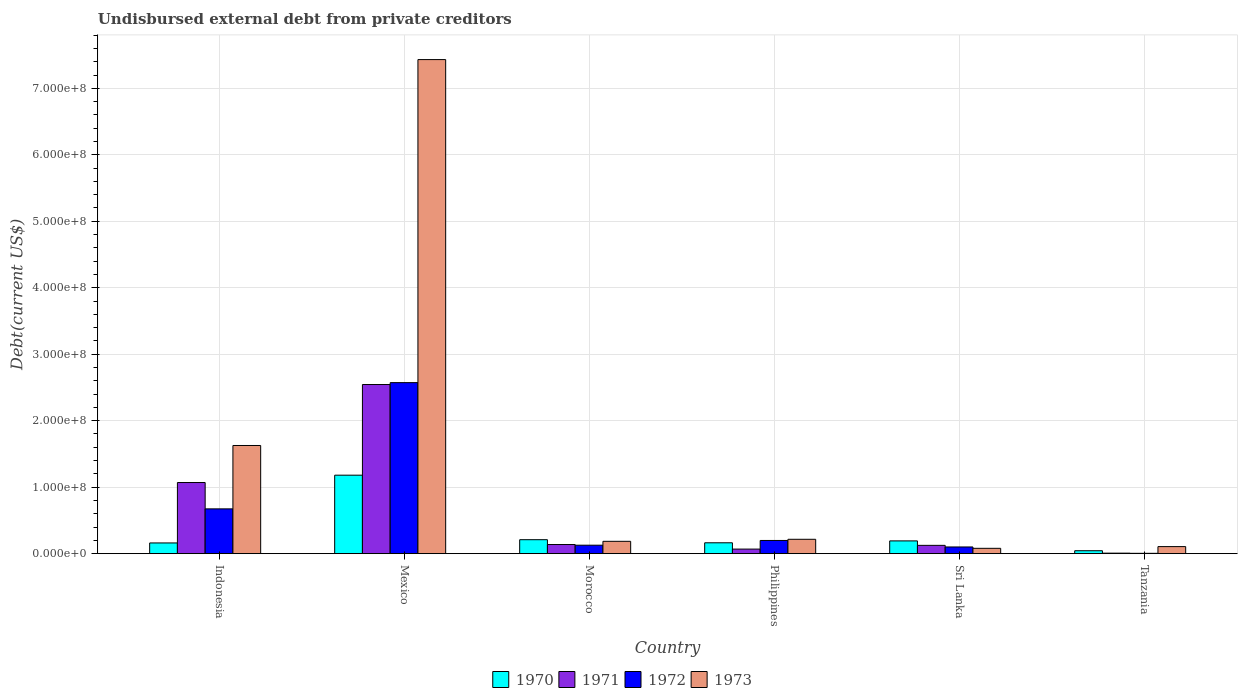How many different coloured bars are there?
Offer a terse response. 4. Are the number of bars on each tick of the X-axis equal?
Your answer should be compact. Yes. How many bars are there on the 5th tick from the left?
Provide a short and direct response. 4. How many bars are there on the 5th tick from the right?
Ensure brevity in your answer.  4. In how many cases, is the number of bars for a given country not equal to the number of legend labels?
Your answer should be compact. 0. What is the total debt in 1973 in Sri Lanka?
Make the answer very short. 8.03e+06. Across all countries, what is the maximum total debt in 1972?
Your answer should be very brief. 2.57e+08. Across all countries, what is the minimum total debt in 1970?
Provide a short and direct response. 4.40e+06. In which country was the total debt in 1970 maximum?
Make the answer very short. Mexico. In which country was the total debt in 1973 minimum?
Keep it short and to the point. Sri Lanka. What is the total total debt in 1970 in the graph?
Provide a short and direct response. 1.95e+08. What is the difference between the total debt in 1972 in Indonesia and that in Tanzania?
Make the answer very short. 6.69e+07. What is the difference between the total debt in 1972 in Mexico and the total debt in 1970 in Tanzania?
Make the answer very short. 2.53e+08. What is the average total debt in 1971 per country?
Your response must be concise. 6.59e+07. What is the difference between the total debt of/in 1973 and total debt of/in 1970 in Indonesia?
Your answer should be very brief. 1.47e+08. In how many countries, is the total debt in 1970 greater than 620000000 US$?
Your answer should be compact. 0. What is the ratio of the total debt in 1971 in Philippines to that in Tanzania?
Offer a terse response. 8.98. What is the difference between the highest and the second highest total debt in 1973?
Your answer should be very brief. 7.22e+08. What is the difference between the highest and the lowest total debt in 1970?
Ensure brevity in your answer.  1.14e+08. What is the difference between two consecutive major ticks on the Y-axis?
Ensure brevity in your answer.  1.00e+08. Are the values on the major ticks of Y-axis written in scientific E-notation?
Your answer should be very brief. Yes. Does the graph contain any zero values?
Provide a short and direct response. No. How many legend labels are there?
Make the answer very short. 4. What is the title of the graph?
Keep it short and to the point. Undisbursed external debt from private creditors. What is the label or title of the X-axis?
Your answer should be compact. Country. What is the label or title of the Y-axis?
Give a very brief answer. Debt(current US$). What is the Debt(current US$) in 1970 in Indonesia?
Your answer should be compact. 1.61e+07. What is the Debt(current US$) of 1971 in Indonesia?
Your response must be concise. 1.07e+08. What is the Debt(current US$) of 1972 in Indonesia?
Your response must be concise. 6.74e+07. What is the Debt(current US$) in 1973 in Indonesia?
Provide a succinct answer. 1.63e+08. What is the Debt(current US$) of 1970 in Mexico?
Give a very brief answer. 1.18e+08. What is the Debt(current US$) in 1971 in Mexico?
Provide a succinct answer. 2.54e+08. What is the Debt(current US$) in 1972 in Mexico?
Make the answer very short. 2.57e+08. What is the Debt(current US$) of 1973 in Mexico?
Your response must be concise. 7.43e+08. What is the Debt(current US$) in 1970 in Morocco?
Your response must be concise. 2.10e+07. What is the Debt(current US$) of 1971 in Morocco?
Keep it short and to the point. 1.37e+07. What is the Debt(current US$) of 1972 in Morocco?
Provide a short and direct response. 1.27e+07. What is the Debt(current US$) of 1973 in Morocco?
Make the answer very short. 1.86e+07. What is the Debt(current US$) of 1970 in Philippines?
Your answer should be very brief. 1.64e+07. What is the Debt(current US$) in 1971 in Philippines?
Your answer should be very brief. 6.87e+06. What is the Debt(current US$) of 1972 in Philippines?
Your answer should be compact. 1.99e+07. What is the Debt(current US$) of 1973 in Philippines?
Offer a terse response. 2.16e+07. What is the Debt(current US$) in 1970 in Sri Lanka?
Your response must be concise. 1.92e+07. What is the Debt(current US$) in 1971 in Sri Lanka?
Ensure brevity in your answer.  1.25e+07. What is the Debt(current US$) in 1972 in Sri Lanka?
Offer a very short reply. 1.01e+07. What is the Debt(current US$) of 1973 in Sri Lanka?
Provide a short and direct response. 8.03e+06. What is the Debt(current US$) in 1970 in Tanzania?
Your response must be concise. 4.40e+06. What is the Debt(current US$) of 1971 in Tanzania?
Provide a succinct answer. 7.65e+05. What is the Debt(current US$) in 1972 in Tanzania?
Give a very brief answer. 5.15e+05. What is the Debt(current US$) of 1973 in Tanzania?
Ensure brevity in your answer.  1.06e+07. Across all countries, what is the maximum Debt(current US$) of 1970?
Your answer should be very brief. 1.18e+08. Across all countries, what is the maximum Debt(current US$) of 1971?
Give a very brief answer. 2.54e+08. Across all countries, what is the maximum Debt(current US$) in 1972?
Offer a very short reply. 2.57e+08. Across all countries, what is the maximum Debt(current US$) of 1973?
Offer a very short reply. 7.43e+08. Across all countries, what is the minimum Debt(current US$) in 1970?
Provide a succinct answer. 4.40e+06. Across all countries, what is the minimum Debt(current US$) of 1971?
Give a very brief answer. 7.65e+05. Across all countries, what is the minimum Debt(current US$) of 1972?
Offer a terse response. 5.15e+05. Across all countries, what is the minimum Debt(current US$) in 1973?
Your answer should be compact. 8.03e+06. What is the total Debt(current US$) of 1970 in the graph?
Make the answer very short. 1.95e+08. What is the total Debt(current US$) of 1971 in the graph?
Make the answer very short. 3.95e+08. What is the total Debt(current US$) in 1972 in the graph?
Your answer should be very brief. 3.68e+08. What is the total Debt(current US$) of 1973 in the graph?
Offer a terse response. 9.65e+08. What is the difference between the Debt(current US$) in 1970 in Indonesia and that in Mexico?
Your answer should be very brief. -1.02e+08. What is the difference between the Debt(current US$) in 1971 in Indonesia and that in Mexico?
Keep it short and to the point. -1.47e+08. What is the difference between the Debt(current US$) in 1972 in Indonesia and that in Mexico?
Your answer should be very brief. -1.90e+08. What is the difference between the Debt(current US$) of 1973 in Indonesia and that in Mexico?
Offer a very short reply. -5.81e+08. What is the difference between the Debt(current US$) of 1970 in Indonesia and that in Morocco?
Your answer should be compact. -4.89e+06. What is the difference between the Debt(current US$) in 1971 in Indonesia and that in Morocco?
Offer a very short reply. 9.33e+07. What is the difference between the Debt(current US$) of 1972 in Indonesia and that in Morocco?
Ensure brevity in your answer.  5.46e+07. What is the difference between the Debt(current US$) of 1973 in Indonesia and that in Morocco?
Make the answer very short. 1.44e+08. What is the difference between the Debt(current US$) in 1970 in Indonesia and that in Philippines?
Give a very brief answer. -2.28e+05. What is the difference between the Debt(current US$) in 1971 in Indonesia and that in Philippines?
Make the answer very short. 1.00e+08. What is the difference between the Debt(current US$) of 1972 in Indonesia and that in Philippines?
Your answer should be very brief. 4.75e+07. What is the difference between the Debt(current US$) of 1973 in Indonesia and that in Philippines?
Keep it short and to the point. 1.41e+08. What is the difference between the Debt(current US$) of 1970 in Indonesia and that in Sri Lanka?
Your answer should be compact. -3.08e+06. What is the difference between the Debt(current US$) in 1971 in Indonesia and that in Sri Lanka?
Make the answer very short. 9.45e+07. What is the difference between the Debt(current US$) of 1972 in Indonesia and that in Sri Lanka?
Give a very brief answer. 5.73e+07. What is the difference between the Debt(current US$) in 1973 in Indonesia and that in Sri Lanka?
Offer a terse response. 1.55e+08. What is the difference between the Debt(current US$) of 1970 in Indonesia and that in Tanzania?
Ensure brevity in your answer.  1.17e+07. What is the difference between the Debt(current US$) of 1971 in Indonesia and that in Tanzania?
Offer a very short reply. 1.06e+08. What is the difference between the Debt(current US$) of 1972 in Indonesia and that in Tanzania?
Keep it short and to the point. 6.69e+07. What is the difference between the Debt(current US$) of 1973 in Indonesia and that in Tanzania?
Provide a short and direct response. 1.52e+08. What is the difference between the Debt(current US$) of 1970 in Mexico and that in Morocco?
Provide a short and direct response. 9.70e+07. What is the difference between the Debt(current US$) of 1971 in Mexico and that in Morocco?
Provide a succinct answer. 2.41e+08. What is the difference between the Debt(current US$) in 1972 in Mexico and that in Morocco?
Give a very brief answer. 2.45e+08. What is the difference between the Debt(current US$) of 1973 in Mexico and that in Morocco?
Your answer should be very brief. 7.25e+08. What is the difference between the Debt(current US$) in 1970 in Mexico and that in Philippines?
Your response must be concise. 1.02e+08. What is the difference between the Debt(current US$) in 1971 in Mexico and that in Philippines?
Your response must be concise. 2.48e+08. What is the difference between the Debt(current US$) in 1972 in Mexico and that in Philippines?
Ensure brevity in your answer.  2.37e+08. What is the difference between the Debt(current US$) of 1973 in Mexico and that in Philippines?
Provide a short and direct response. 7.22e+08. What is the difference between the Debt(current US$) of 1970 in Mexico and that in Sri Lanka?
Your answer should be very brief. 9.88e+07. What is the difference between the Debt(current US$) of 1971 in Mexico and that in Sri Lanka?
Give a very brief answer. 2.42e+08. What is the difference between the Debt(current US$) of 1972 in Mexico and that in Sri Lanka?
Make the answer very short. 2.47e+08. What is the difference between the Debt(current US$) in 1973 in Mexico and that in Sri Lanka?
Give a very brief answer. 7.35e+08. What is the difference between the Debt(current US$) of 1970 in Mexico and that in Tanzania?
Give a very brief answer. 1.14e+08. What is the difference between the Debt(current US$) in 1971 in Mexico and that in Tanzania?
Your response must be concise. 2.54e+08. What is the difference between the Debt(current US$) of 1972 in Mexico and that in Tanzania?
Your answer should be compact. 2.57e+08. What is the difference between the Debt(current US$) in 1973 in Mexico and that in Tanzania?
Provide a succinct answer. 7.33e+08. What is the difference between the Debt(current US$) in 1970 in Morocco and that in Philippines?
Offer a very short reply. 4.66e+06. What is the difference between the Debt(current US$) in 1971 in Morocco and that in Philippines?
Provide a succinct answer. 6.88e+06. What is the difference between the Debt(current US$) of 1972 in Morocco and that in Philippines?
Ensure brevity in your answer.  -7.12e+06. What is the difference between the Debt(current US$) of 1973 in Morocco and that in Philippines?
Offer a terse response. -3.06e+06. What is the difference between the Debt(current US$) in 1970 in Morocco and that in Sri Lanka?
Your response must be concise. 1.82e+06. What is the difference between the Debt(current US$) in 1971 in Morocco and that in Sri Lanka?
Offer a very short reply. 1.26e+06. What is the difference between the Debt(current US$) in 1972 in Morocco and that in Sri Lanka?
Offer a very short reply. 2.67e+06. What is the difference between the Debt(current US$) in 1973 in Morocco and that in Sri Lanka?
Your answer should be very brief. 1.05e+07. What is the difference between the Debt(current US$) in 1970 in Morocco and that in Tanzania?
Provide a short and direct response. 1.66e+07. What is the difference between the Debt(current US$) in 1971 in Morocco and that in Tanzania?
Give a very brief answer. 1.30e+07. What is the difference between the Debt(current US$) of 1972 in Morocco and that in Tanzania?
Keep it short and to the point. 1.22e+07. What is the difference between the Debt(current US$) of 1973 in Morocco and that in Tanzania?
Make the answer very short. 7.94e+06. What is the difference between the Debt(current US$) in 1970 in Philippines and that in Sri Lanka?
Your answer should be very brief. -2.85e+06. What is the difference between the Debt(current US$) in 1971 in Philippines and that in Sri Lanka?
Keep it short and to the point. -5.62e+06. What is the difference between the Debt(current US$) of 1972 in Philippines and that in Sri Lanka?
Make the answer very short. 9.78e+06. What is the difference between the Debt(current US$) in 1973 in Philippines and that in Sri Lanka?
Offer a terse response. 1.36e+07. What is the difference between the Debt(current US$) in 1970 in Philippines and that in Tanzania?
Your response must be concise. 1.20e+07. What is the difference between the Debt(current US$) in 1971 in Philippines and that in Tanzania?
Your answer should be compact. 6.11e+06. What is the difference between the Debt(current US$) of 1972 in Philippines and that in Tanzania?
Your answer should be very brief. 1.93e+07. What is the difference between the Debt(current US$) of 1973 in Philippines and that in Tanzania?
Offer a terse response. 1.10e+07. What is the difference between the Debt(current US$) of 1970 in Sri Lanka and that in Tanzania?
Your answer should be compact. 1.48e+07. What is the difference between the Debt(current US$) in 1971 in Sri Lanka and that in Tanzania?
Your answer should be very brief. 1.17e+07. What is the difference between the Debt(current US$) of 1972 in Sri Lanka and that in Tanzania?
Your answer should be very brief. 9.56e+06. What is the difference between the Debt(current US$) in 1973 in Sri Lanka and that in Tanzania?
Your response must be concise. -2.59e+06. What is the difference between the Debt(current US$) in 1970 in Indonesia and the Debt(current US$) in 1971 in Mexico?
Provide a succinct answer. -2.38e+08. What is the difference between the Debt(current US$) of 1970 in Indonesia and the Debt(current US$) of 1972 in Mexico?
Provide a succinct answer. -2.41e+08. What is the difference between the Debt(current US$) in 1970 in Indonesia and the Debt(current US$) in 1973 in Mexico?
Your answer should be compact. -7.27e+08. What is the difference between the Debt(current US$) in 1971 in Indonesia and the Debt(current US$) in 1972 in Mexico?
Your answer should be very brief. -1.50e+08. What is the difference between the Debt(current US$) of 1971 in Indonesia and the Debt(current US$) of 1973 in Mexico?
Your response must be concise. -6.36e+08. What is the difference between the Debt(current US$) of 1972 in Indonesia and the Debt(current US$) of 1973 in Mexico?
Give a very brief answer. -6.76e+08. What is the difference between the Debt(current US$) of 1970 in Indonesia and the Debt(current US$) of 1971 in Morocco?
Your answer should be compact. 2.38e+06. What is the difference between the Debt(current US$) in 1970 in Indonesia and the Debt(current US$) in 1972 in Morocco?
Your response must be concise. 3.39e+06. What is the difference between the Debt(current US$) in 1970 in Indonesia and the Debt(current US$) in 1973 in Morocco?
Your response must be concise. -2.44e+06. What is the difference between the Debt(current US$) of 1971 in Indonesia and the Debt(current US$) of 1972 in Morocco?
Offer a very short reply. 9.43e+07. What is the difference between the Debt(current US$) in 1971 in Indonesia and the Debt(current US$) in 1973 in Morocco?
Give a very brief answer. 8.85e+07. What is the difference between the Debt(current US$) of 1972 in Indonesia and the Debt(current US$) of 1973 in Morocco?
Give a very brief answer. 4.88e+07. What is the difference between the Debt(current US$) of 1970 in Indonesia and the Debt(current US$) of 1971 in Philippines?
Your answer should be very brief. 9.25e+06. What is the difference between the Debt(current US$) in 1970 in Indonesia and the Debt(current US$) in 1972 in Philippines?
Ensure brevity in your answer.  -3.73e+06. What is the difference between the Debt(current US$) of 1970 in Indonesia and the Debt(current US$) of 1973 in Philippines?
Make the answer very short. -5.49e+06. What is the difference between the Debt(current US$) of 1971 in Indonesia and the Debt(current US$) of 1972 in Philippines?
Give a very brief answer. 8.72e+07. What is the difference between the Debt(current US$) of 1971 in Indonesia and the Debt(current US$) of 1973 in Philippines?
Give a very brief answer. 8.54e+07. What is the difference between the Debt(current US$) of 1972 in Indonesia and the Debt(current US$) of 1973 in Philippines?
Your response must be concise. 4.58e+07. What is the difference between the Debt(current US$) of 1970 in Indonesia and the Debt(current US$) of 1971 in Sri Lanka?
Ensure brevity in your answer.  3.63e+06. What is the difference between the Debt(current US$) of 1970 in Indonesia and the Debt(current US$) of 1972 in Sri Lanka?
Provide a short and direct response. 6.05e+06. What is the difference between the Debt(current US$) of 1970 in Indonesia and the Debt(current US$) of 1973 in Sri Lanka?
Your answer should be very brief. 8.10e+06. What is the difference between the Debt(current US$) in 1971 in Indonesia and the Debt(current US$) in 1972 in Sri Lanka?
Your answer should be compact. 9.69e+07. What is the difference between the Debt(current US$) in 1971 in Indonesia and the Debt(current US$) in 1973 in Sri Lanka?
Ensure brevity in your answer.  9.90e+07. What is the difference between the Debt(current US$) of 1972 in Indonesia and the Debt(current US$) of 1973 in Sri Lanka?
Offer a very short reply. 5.93e+07. What is the difference between the Debt(current US$) in 1970 in Indonesia and the Debt(current US$) in 1971 in Tanzania?
Your answer should be compact. 1.54e+07. What is the difference between the Debt(current US$) of 1970 in Indonesia and the Debt(current US$) of 1972 in Tanzania?
Offer a terse response. 1.56e+07. What is the difference between the Debt(current US$) in 1970 in Indonesia and the Debt(current US$) in 1973 in Tanzania?
Give a very brief answer. 5.51e+06. What is the difference between the Debt(current US$) in 1971 in Indonesia and the Debt(current US$) in 1972 in Tanzania?
Offer a very short reply. 1.06e+08. What is the difference between the Debt(current US$) in 1971 in Indonesia and the Debt(current US$) in 1973 in Tanzania?
Make the answer very short. 9.64e+07. What is the difference between the Debt(current US$) of 1972 in Indonesia and the Debt(current US$) of 1973 in Tanzania?
Offer a very short reply. 5.68e+07. What is the difference between the Debt(current US$) in 1970 in Mexico and the Debt(current US$) in 1971 in Morocco?
Offer a terse response. 1.04e+08. What is the difference between the Debt(current US$) in 1970 in Mexico and the Debt(current US$) in 1972 in Morocco?
Your response must be concise. 1.05e+08. What is the difference between the Debt(current US$) in 1970 in Mexico and the Debt(current US$) in 1973 in Morocco?
Offer a terse response. 9.95e+07. What is the difference between the Debt(current US$) in 1971 in Mexico and the Debt(current US$) in 1972 in Morocco?
Your answer should be compact. 2.42e+08. What is the difference between the Debt(current US$) in 1971 in Mexico and the Debt(current US$) in 1973 in Morocco?
Offer a terse response. 2.36e+08. What is the difference between the Debt(current US$) of 1972 in Mexico and the Debt(current US$) of 1973 in Morocco?
Give a very brief answer. 2.39e+08. What is the difference between the Debt(current US$) of 1970 in Mexico and the Debt(current US$) of 1971 in Philippines?
Your answer should be compact. 1.11e+08. What is the difference between the Debt(current US$) in 1970 in Mexico and the Debt(current US$) in 1972 in Philippines?
Your answer should be compact. 9.82e+07. What is the difference between the Debt(current US$) in 1970 in Mexico and the Debt(current US$) in 1973 in Philippines?
Offer a very short reply. 9.64e+07. What is the difference between the Debt(current US$) of 1971 in Mexico and the Debt(current US$) of 1972 in Philippines?
Your response must be concise. 2.35e+08. What is the difference between the Debt(current US$) of 1971 in Mexico and the Debt(current US$) of 1973 in Philippines?
Ensure brevity in your answer.  2.33e+08. What is the difference between the Debt(current US$) of 1972 in Mexico and the Debt(current US$) of 1973 in Philippines?
Make the answer very short. 2.36e+08. What is the difference between the Debt(current US$) of 1970 in Mexico and the Debt(current US$) of 1971 in Sri Lanka?
Provide a succinct answer. 1.06e+08. What is the difference between the Debt(current US$) of 1970 in Mexico and the Debt(current US$) of 1972 in Sri Lanka?
Provide a short and direct response. 1.08e+08. What is the difference between the Debt(current US$) in 1970 in Mexico and the Debt(current US$) in 1973 in Sri Lanka?
Offer a terse response. 1.10e+08. What is the difference between the Debt(current US$) of 1971 in Mexico and the Debt(current US$) of 1972 in Sri Lanka?
Provide a short and direct response. 2.44e+08. What is the difference between the Debt(current US$) of 1971 in Mexico and the Debt(current US$) of 1973 in Sri Lanka?
Offer a very short reply. 2.46e+08. What is the difference between the Debt(current US$) in 1972 in Mexico and the Debt(current US$) in 1973 in Sri Lanka?
Give a very brief answer. 2.49e+08. What is the difference between the Debt(current US$) of 1970 in Mexico and the Debt(current US$) of 1971 in Tanzania?
Keep it short and to the point. 1.17e+08. What is the difference between the Debt(current US$) of 1970 in Mexico and the Debt(current US$) of 1972 in Tanzania?
Give a very brief answer. 1.18e+08. What is the difference between the Debt(current US$) in 1970 in Mexico and the Debt(current US$) in 1973 in Tanzania?
Your response must be concise. 1.07e+08. What is the difference between the Debt(current US$) of 1971 in Mexico and the Debt(current US$) of 1972 in Tanzania?
Your answer should be compact. 2.54e+08. What is the difference between the Debt(current US$) of 1971 in Mexico and the Debt(current US$) of 1973 in Tanzania?
Offer a very short reply. 2.44e+08. What is the difference between the Debt(current US$) of 1972 in Mexico and the Debt(current US$) of 1973 in Tanzania?
Keep it short and to the point. 2.47e+08. What is the difference between the Debt(current US$) in 1970 in Morocco and the Debt(current US$) in 1971 in Philippines?
Offer a terse response. 1.41e+07. What is the difference between the Debt(current US$) of 1970 in Morocco and the Debt(current US$) of 1972 in Philippines?
Your answer should be very brief. 1.16e+06. What is the difference between the Debt(current US$) in 1970 in Morocco and the Debt(current US$) in 1973 in Philippines?
Your answer should be compact. -6.03e+05. What is the difference between the Debt(current US$) of 1971 in Morocco and the Debt(current US$) of 1972 in Philippines?
Your answer should be very brief. -6.10e+06. What is the difference between the Debt(current US$) in 1971 in Morocco and the Debt(current US$) in 1973 in Philippines?
Offer a terse response. -7.87e+06. What is the difference between the Debt(current US$) in 1972 in Morocco and the Debt(current US$) in 1973 in Philippines?
Your answer should be compact. -8.88e+06. What is the difference between the Debt(current US$) of 1970 in Morocco and the Debt(current US$) of 1971 in Sri Lanka?
Provide a succinct answer. 8.52e+06. What is the difference between the Debt(current US$) in 1970 in Morocco and the Debt(current US$) in 1972 in Sri Lanka?
Provide a short and direct response. 1.09e+07. What is the difference between the Debt(current US$) of 1970 in Morocco and the Debt(current US$) of 1973 in Sri Lanka?
Your answer should be very brief. 1.30e+07. What is the difference between the Debt(current US$) in 1971 in Morocco and the Debt(current US$) in 1972 in Sri Lanka?
Make the answer very short. 3.68e+06. What is the difference between the Debt(current US$) in 1971 in Morocco and the Debt(current US$) in 1973 in Sri Lanka?
Make the answer very short. 5.72e+06. What is the difference between the Debt(current US$) of 1972 in Morocco and the Debt(current US$) of 1973 in Sri Lanka?
Provide a succinct answer. 4.71e+06. What is the difference between the Debt(current US$) in 1970 in Morocco and the Debt(current US$) in 1971 in Tanzania?
Your answer should be very brief. 2.02e+07. What is the difference between the Debt(current US$) of 1970 in Morocco and the Debt(current US$) of 1972 in Tanzania?
Offer a very short reply. 2.05e+07. What is the difference between the Debt(current US$) in 1970 in Morocco and the Debt(current US$) in 1973 in Tanzania?
Give a very brief answer. 1.04e+07. What is the difference between the Debt(current US$) in 1971 in Morocco and the Debt(current US$) in 1972 in Tanzania?
Offer a very short reply. 1.32e+07. What is the difference between the Debt(current US$) of 1971 in Morocco and the Debt(current US$) of 1973 in Tanzania?
Provide a short and direct response. 3.13e+06. What is the difference between the Debt(current US$) of 1972 in Morocco and the Debt(current US$) of 1973 in Tanzania?
Your answer should be very brief. 2.12e+06. What is the difference between the Debt(current US$) of 1970 in Philippines and the Debt(current US$) of 1971 in Sri Lanka?
Keep it short and to the point. 3.86e+06. What is the difference between the Debt(current US$) in 1970 in Philippines and the Debt(current US$) in 1972 in Sri Lanka?
Your response must be concise. 6.28e+06. What is the difference between the Debt(current US$) of 1970 in Philippines and the Debt(current US$) of 1973 in Sri Lanka?
Your answer should be compact. 8.32e+06. What is the difference between the Debt(current US$) of 1971 in Philippines and the Debt(current US$) of 1972 in Sri Lanka?
Give a very brief answer. -3.20e+06. What is the difference between the Debt(current US$) in 1971 in Philippines and the Debt(current US$) in 1973 in Sri Lanka?
Offer a very short reply. -1.16e+06. What is the difference between the Debt(current US$) in 1972 in Philippines and the Debt(current US$) in 1973 in Sri Lanka?
Your answer should be compact. 1.18e+07. What is the difference between the Debt(current US$) in 1970 in Philippines and the Debt(current US$) in 1971 in Tanzania?
Offer a very short reply. 1.56e+07. What is the difference between the Debt(current US$) of 1970 in Philippines and the Debt(current US$) of 1972 in Tanzania?
Offer a terse response. 1.58e+07. What is the difference between the Debt(current US$) in 1970 in Philippines and the Debt(current US$) in 1973 in Tanzania?
Your answer should be compact. 5.74e+06. What is the difference between the Debt(current US$) of 1971 in Philippines and the Debt(current US$) of 1972 in Tanzania?
Make the answer very short. 6.36e+06. What is the difference between the Debt(current US$) in 1971 in Philippines and the Debt(current US$) in 1973 in Tanzania?
Ensure brevity in your answer.  -3.74e+06. What is the difference between the Debt(current US$) of 1972 in Philippines and the Debt(current US$) of 1973 in Tanzania?
Provide a succinct answer. 9.24e+06. What is the difference between the Debt(current US$) in 1970 in Sri Lanka and the Debt(current US$) in 1971 in Tanzania?
Offer a terse response. 1.84e+07. What is the difference between the Debt(current US$) of 1970 in Sri Lanka and the Debt(current US$) of 1972 in Tanzania?
Provide a short and direct response. 1.87e+07. What is the difference between the Debt(current US$) of 1970 in Sri Lanka and the Debt(current US$) of 1973 in Tanzania?
Give a very brief answer. 8.58e+06. What is the difference between the Debt(current US$) in 1971 in Sri Lanka and the Debt(current US$) in 1972 in Tanzania?
Your answer should be compact. 1.20e+07. What is the difference between the Debt(current US$) of 1971 in Sri Lanka and the Debt(current US$) of 1973 in Tanzania?
Your response must be concise. 1.87e+06. What is the difference between the Debt(current US$) of 1972 in Sri Lanka and the Debt(current US$) of 1973 in Tanzania?
Your response must be concise. -5.46e+05. What is the average Debt(current US$) in 1970 per country?
Give a very brief answer. 3.25e+07. What is the average Debt(current US$) of 1971 per country?
Your answer should be very brief. 6.59e+07. What is the average Debt(current US$) in 1972 per country?
Your response must be concise. 6.13e+07. What is the average Debt(current US$) in 1973 per country?
Your response must be concise. 1.61e+08. What is the difference between the Debt(current US$) in 1970 and Debt(current US$) in 1971 in Indonesia?
Offer a very short reply. -9.09e+07. What is the difference between the Debt(current US$) of 1970 and Debt(current US$) of 1972 in Indonesia?
Give a very brief answer. -5.12e+07. What is the difference between the Debt(current US$) in 1970 and Debt(current US$) in 1973 in Indonesia?
Give a very brief answer. -1.47e+08. What is the difference between the Debt(current US$) of 1971 and Debt(current US$) of 1972 in Indonesia?
Make the answer very short. 3.96e+07. What is the difference between the Debt(current US$) in 1971 and Debt(current US$) in 1973 in Indonesia?
Your answer should be very brief. -5.57e+07. What is the difference between the Debt(current US$) of 1972 and Debt(current US$) of 1973 in Indonesia?
Your response must be concise. -9.53e+07. What is the difference between the Debt(current US$) of 1970 and Debt(current US$) of 1971 in Mexico?
Keep it short and to the point. -1.36e+08. What is the difference between the Debt(current US$) in 1970 and Debt(current US$) in 1972 in Mexico?
Offer a very short reply. -1.39e+08. What is the difference between the Debt(current US$) of 1970 and Debt(current US$) of 1973 in Mexico?
Provide a succinct answer. -6.25e+08. What is the difference between the Debt(current US$) in 1971 and Debt(current US$) in 1972 in Mexico?
Your answer should be compact. -2.84e+06. What is the difference between the Debt(current US$) in 1971 and Debt(current US$) in 1973 in Mexico?
Ensure brevity in your answer.  -4.89e+08. What is the difference between the Debt(current US$) of 1972 and Debt(current US$) of 1973 in Mexico?
Keep it short and to the point. -4.86e+08. What is the difference between the Debt(current US$) of 1970 and Debt(current US$) of 1971 in Morocco?
Your answer should be compact. 7.27e+06. What is the difference between the Debt(current US$) of 1970 and Debt(current US$) of 1972 in Morocco?
Give a very brief answer. 8.28e+06. What is the difference between the Debt(current US$) in 1970 and Debt(current US$) in 1973 in Morocco?
Keep it short and to the point. 2.45e+06. What is the difference between the Debt(current US$) of 1971 and Debt(current US$) of 1972 in Morocco?
Provide a short and direct response. 1.01e+06. What is the difference between the Debt(current US$) of 1971 and Debt(current US$) of 1973 in Morocco?
Offer a very short reply. -4.81e+06. What is the difference between the Debt(current US$) of 1972 and Debt(current US$) of 1973 in Morocco?
Offer a very short reply. -5.82e+06. What is the difference between the Debt(current US$) of 1970 and Debt(current US$) of 1971 in Philippines?
Your response must be concise. 9.48e+06. What is the difference between the Debt(current US$) in 1970 and Debt(current US$) in 1972 in Philippines?
Your answer should be very brief. -3.50e+06. What is the difference between the Debt(current US$) in 1970 and Debt(current US$) in 1973 in Philippines?
Make the answer very short. -5.27e+06. What is the difference between the Debt(current US$) of 1971 and Debt(current US$) of 1972 in Philippines?
Your answer should be compact. -1.30e+07. What is the difference between the Debt(current US$) of 1971 and Debt(current US$) of 1973 in Philippines?
Keep it short and to the point. -1.47e+07. What is the difference between the Debt(current US$) in 1972 and Debt(current US$) in 1973 in Philippines?
Offer a terse response. -1.76e+06. What is the difference between the Debt(current US$) in 1970 and Debt(current US$) in 1971 in Sri Lanka?
Offer a very short reply. 6.71e+06. What is the difference between the Debt(current US$) in 1970 and Debt(current US$) in 1972 in Sri Lanka?
Your answer should be compact. 9.13e+06. What is the difference between the Debt(current US$) of 1970 and Debt(current US$) of 1973 in Sri Lanka?
Offer a very short reply. 1.12e+07. What is the difference between the Debt(current US$) of 1971 and Debt(current US$) of 1972 in Sri Lanka?
Your answer should be compact. 2.42e+06. What is the difference between the Debt(current US$) in 1971 and Debt(current US$) in 1973 in Sri Lanka?
Your response must be concise. 4.46e+06. What is the difference between the Debt(current US$) of 1972 and Debt(current US$) of 1973 in Sri Lanka?
Provide a short and direct response. 2.04e+06. What is the difference between the Debt(current US$) of 1970 and Debt(current US$) of 1971 in Tanzania?
Ensure brevity in your answer.  3.64e+06. What is the difference between the Debt(current US$) of 1970 and Debt(current US$) of 1972 in Tanzania?
Your answer should be compact. 3.88e+06. What is the difference between the Debt(current US$) of 1970 and Debt(current US$) of 1973 in Tanzania?
Ensure brevity in your answer.  -6.22e+06. What is the difference between the Debt(current US$) in 1971 and Debt(current US$) in 1972 in Tanzania?
Provide a short and direct response. 2.50e+05. What is the difference between the Debt(current US$) of 1971 and Debt(current US$) of 1973 in Tanzania?
Your answer should be compact. -9.85e+06. What is the difference between the Debt(current US$) of 1972 and Debt(current US$) of 1973 in Tanzania?
Provide a succinct answer. -1.01e+07. What is the ratio of the Debt(current US$) of 1970 in Indonesia to that in Mexico?
Provide a succinct answer. 0.14. What is the ratio of the Debt(current US$) of 1971 in Indonesia to that in Mexico?
Give a very brief answer. 0.42. What is the ratio of the Debt(current US$) of 1972 in Indonesia to that in Mexico?
Your answer should be compact. 0.26. What is the ratio of the Debt(current US$) in 1973 in Indonesia to that in Mexico?
Provide a succinct answer. 0.22. What is the ratio of the Debt(current US$) of 1970 in Indonesia to that in Morocco?
Offer a terse response. 0.77. What is the ratio of the Debt(current US$) of 1971 in Indonesia to that in Morocco?
Make the answer very short. 7.78. What is the ratio of the Debt(current US$) in 1972 in Indonesia to that in Morocco?
Offer a terse response. 5.29. What is the ratio of the Debt(current US$) of 1973 in Indonesia to that in Morocco?
Offer a very short reply. 8.77. What is the ratio of the Debt(current US$) in 1970 in Indonesia to that in Philippines?
Offer a terse response. 0.99. What is the ratio of the Debt(current US$) of 1971 in Indonesia to that in Philippines?
Ensure brevity in your answer.  15.57. What is the ratio of the Debt(current US$) in 1972 in Indonesia to that in Philippines?
Provide a short and direct response. 3.39. What is the ratio of the Debt(current US$) in 1973 in Indonesia to that in Philippines?
Your answer should be compact. 7.53. What is the ratio of the Debt(current US$) of 1970 in Indonesia to that in Sri Lanka?
Your answer should be compact. 0.84. What is the ratio of the Debt(current US$) of 1971 in Indonesia to that in Sri Lanka?
Provide a short and direct response. 8.57. What is the ratio of the Debt(current US$) in 1972 in Indonesia to that in Sri Lanka?
Give a very brief answer. 6.69. What is the ratio of the Debt(current US$) in 1973 in Indonesia to that in Sri Lanka?
Keep it short and to the point. 20.27. What is the ratio of the Debt(current US$) of 1970 in Indonesia to that in Tanzania?
Keep it short and to the point. 3.66. What is the ratio of the Debt(current US$) of 1971 in Indonesia to that in Tanzania?
Keep it short and to the point. 139.89. What is the ratio of the Debt(current US$) of 1972 in Indonesia to that in Tanzania?
Provide a succinct answer. 130.82. What is the ratio of the Debt(current US$) in 1973 in Indonesia to that in Tanzania?
Make the answer very short. 15.33. What is the ratio of the Debt(current US$) in 1970 in Mexico to that in Morocco?
Provide a short and direct response. 5.62. What is the ratio of the Debt(current US$) of 1971 in Mexico to that in Morocco?
Your response must be concise. 18.51. What is the ratio of the Debt(current US$) of 1972 in Mexico to that in Morocco?
Provide a short and direct response. 20.2. What is the ratio of the Debt(current US$) in 1973 in Mexico to that in Morocco?
Provide a short and direct response. 40.04. What is the ratio of the Debt(current US$) in 1970 in Mexico to that in Philippines?
Your answer should be very brief. 7.22. What is the ratio of the Debt(current US$) of 1971 in Mexico to that in Philippines?
Provide a succinct answer. 37.02. What is the ratio of the Debt(current US$) of 1972 in Mexico to that in Philippines?
Provide a succinct answer. 12.96. What is the ratio of the Debt(current US$) of 1973 in Mexico to that in Philippines?
Give a very brief answer. 34.38. What is the ratio of the Debt(current US$) in 1970 in Mexico to that in Sri Lanka?
Make the answer very short. 6.15. What is the ratio of the Debt(current US$) of 1971 in Mexico to that in Sri Lanka?
Keep it short and to the point. 20.37. What is the ratio of the Debt(current US$) of 1972 in Mexico to that in Sri Lanka?
Your response must be concise. 25.55. What is the ratio of the Debt(current US$) in 1973 in Mexico to that in Sri Lanka?
Ensure brevity in your answer.  92.59. What is the ratio of the Debt(current US$) of 1970 in Mexico to that in Tanzania?
Offer a very short reply. 26.83. What is the ratio of the Debt(current US$) of 1971 in Mexico to that in Tanzania?
Offer a very short reply. 332.59. What is the ratio of the Debt(current US$) in 1972 in Mexico to that in Tanzania?
Make the answer very short. 499.54. What is the ratio of the Debt(current US$) in 1973 in Mexico to that in Tanzania?
Provide a short and direct response. 70.01. What is the ratio of the Debt(current US$) in 1970 in Morocco to that in Philippines?
Provide a succinct answer. 1.29. What is the ratio of the Debt(current US$) in 1971 in Morocco to that in Philippines?
Offer a very short reply. 2. What is the ratio of the Debt(current US$) in 1972 in Morocco to that in Philippines?
Your answer should be compact. 0.64. What is the ratio of the Debt(current US$) in 1973 in Morocco to that in Philippines?
Provide a short and direct response. 0.86. What is the ratio of the Debt(current US$) in 1970 in Morocco to that in Sri Lanka?
Keep it short and to the point. 1.09. What is the ratio of the Debt(current US$) of 1971 in Morocco to that in Sri Lanka?
Make the answer very short. 1.1. What is the ratio of the Debt(current US$) of 1972 in Morocco to that in Sri Lanka?
Your response must be concise. 1.26. What is the ratio of the Debt(current US$) in 1973 in Morocco to that in Sri Lanka?
Offer a terse response. 2.31. What is the ratio of the Debt(current US$) of 1970 in Morocco to that in Tanzania?
Make the answer very short. 4.78. What is the ratio of the Debt(current US$) of 1971 in Morocco to that in Tanzania?
Provide a succinct answer. 17.97. What is the ratio of the Debt(current US$) of 1972 in Morocco to that in Tanzania?
Your answer should be compact. 24.73. What is the ratio of the Debt(current US$) of 1973 in Morocco to that in Tanzania?
Make the answer very short. 1.75. What is the ratio of the Debt(current US$) in 1970 in Philippines to that in Sri Lanka?
Provide a short and direct response. 0.85. What is the ratio of the Debt(current US$) of 1971 in Philippines to that in Sri Lanka?
Your response must be concise. 0.55. What is the ratio of the Debt(current US$) of 1972 in Philippines to that in Sri Lanka?
Make the answer very short. 1.97. What is the ratio of the Debt(current US$) in 1973 in Philippines to that in Sri Lanka?
Make the answer very short. 2.69. What is the ratio of the Debt(current US$) of 1970 in Philippines to that in Tanzania?
Offer a very short reply. 3.72. What is the ratio of the Debt(current US$) of 1971 in Philippines to that in Tanzania?
Keep it short and to the point. 8.98. What is the ratio of the Debt(current US$) in 1972 in Philippines to that in Tanzania?
Your answer should be compact. 38.55. What is the ratio of the Debt(current US$) in 1973 in Philippines to that in Tanzania?
Your answer should be compact. 2.04. What is the ratio of the Debt(current US$) in 1970 in Sri Lanka to that in Tanzania?
Offer a very short reply. 4.36. What is the ratio of the Debt(current US$) of 1971 in Sri Lanka to that in Tanzania?
Make the answer very short. 16.33. What is the ratio of the Debt(current US$) in 1972 in Sri Lanka to that in Tanzania?
Give a very brief answer. 19.55. What is the ratio of the Debt(current US$) in 1973 in Sri Lanka to that in Tanzania?
Your answer should be compact. 0.76. What is the difference between the highest and the second highest Debt(current US$) in 1970?
Make the answer very short. 9.70e+07. What is the difference between the highest and the second highest Debt(current US$) of 1971?
Give a very brief answer. 1.47e+08. What is the difference between the highest and the second highest Debt(current US$) of 1972?
Your answer should be very brief. 1.90e+08. What is the difference between the highest and the second highest Debt(current US$) in 1973?
Provide a short and direct response. 5.81e+08. What is the difference between the highest and the lowest Debt(current US$) in 1970?
Offer a very short reply. 1.14e+08. What is the difference between the highest and the lowest Debt(current US$) in 1971?
Your answer should be very brief. 2.54e+08. What is the difference between the highest and the lowest Debt(current US$) of 1972?
Offer a terse response. 2.57e+08. What is the difference between the highest and the lowest Debt(current US$) in 1973?
Provide a succinct answer. 7.35e+08. 